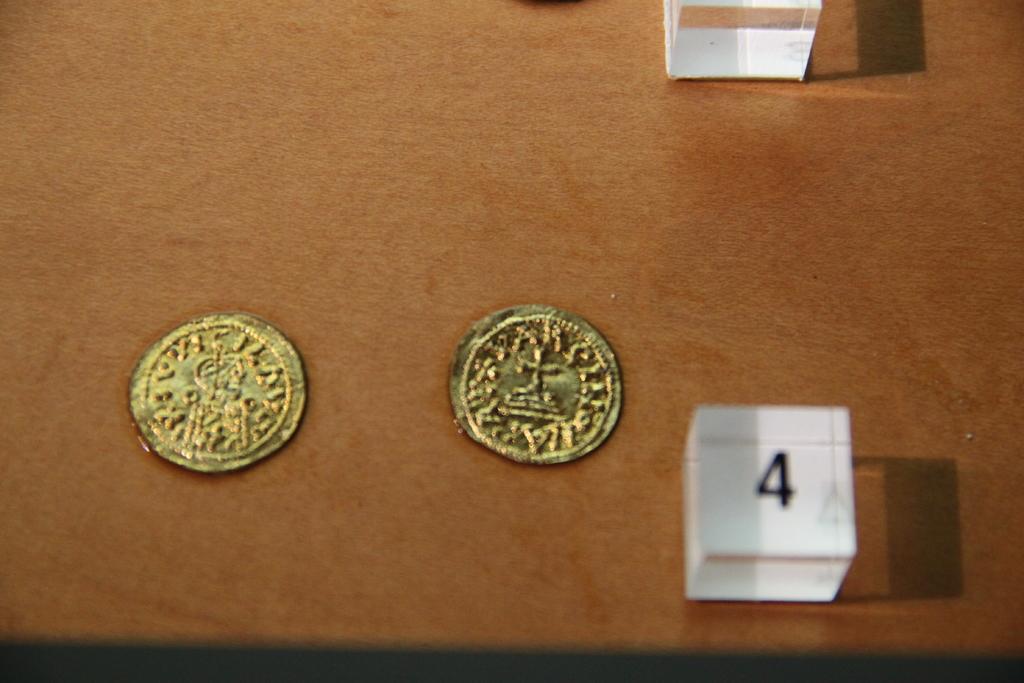What number is on the white cube?
Your answer should be very brief. 4. 